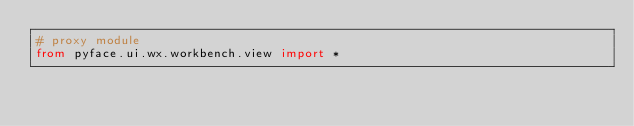Convert code to text. <code><loc_0><loc_0><loc_500><loc_500><_Python_># proxy module
from pyface.ui.wx.workbench.view import *
</code> 